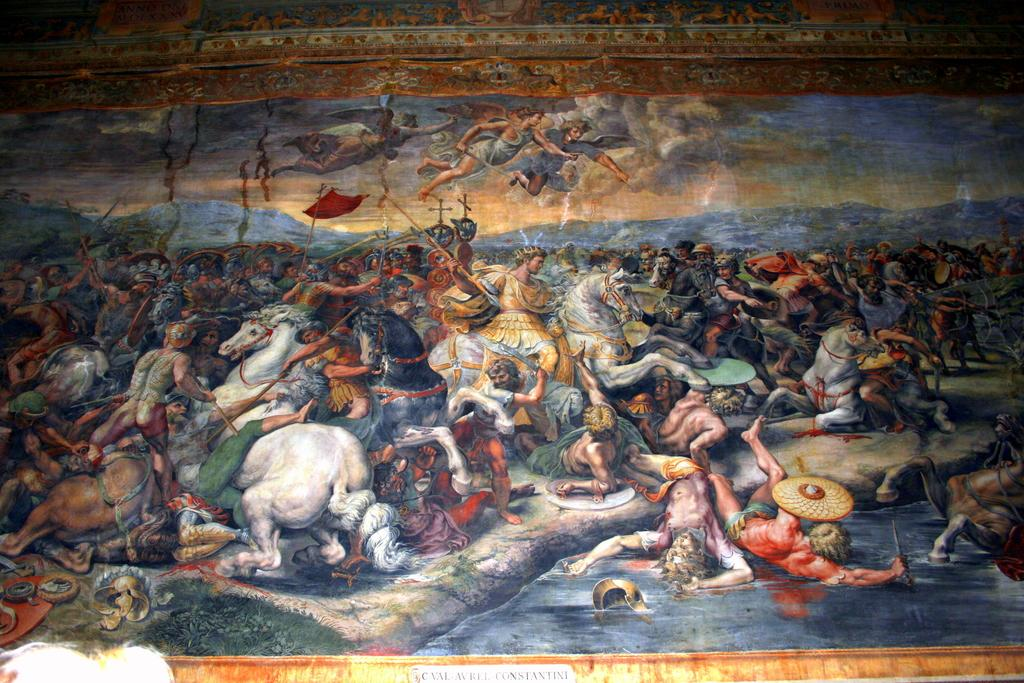What type of visual representation is shown in the image? The image is a poster. Who or what can be seen in the image? There is a group of people and horses in the image. What is the setting of the image? The image features water, mountains, and a visible sky with clouds. Are there any objects present in the image? Yes, there are some objects in the image. What type of insurance is being advertised in the image? There is no indication of insurance being advertised in the image; it features a group of people, horses, water, mountains, and a sky with clouds. What knowledge can be gained from the image about the work of the people depicted? The image does not provide any information about the work of the people depicted, as it focuses on their presence in a natural setting with horses, water, mountains, and a sky with clouds. 